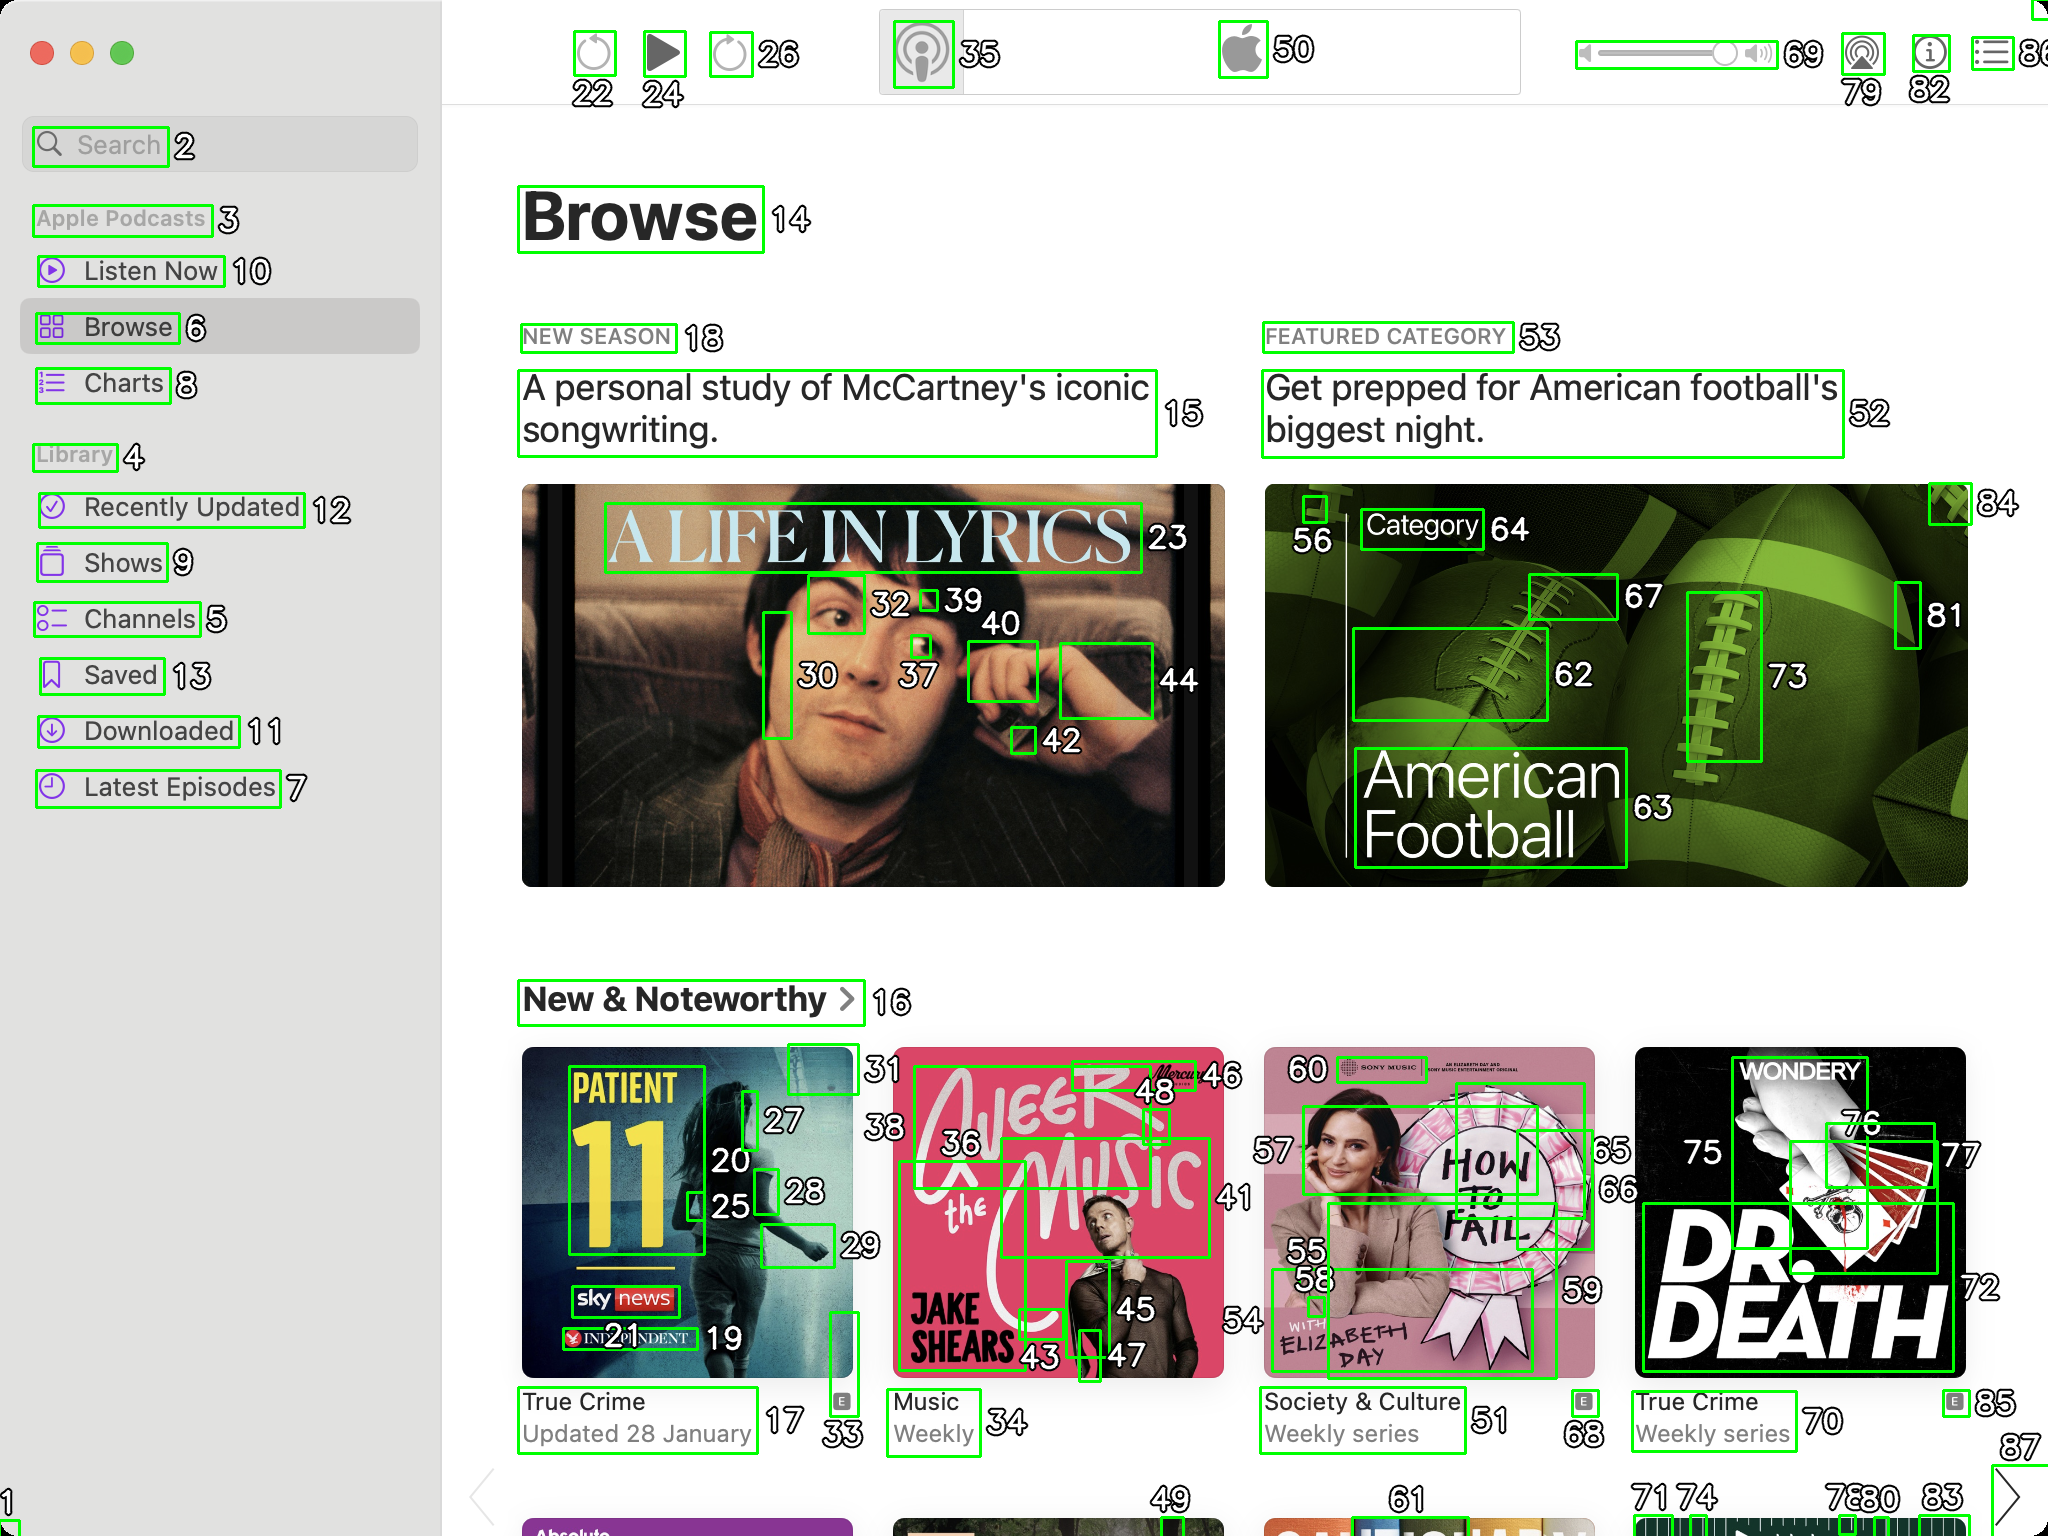You are an AI designed for image processing and segmentation analysis, particularly skilled in merging segmented regions of an image to improve accuracy and readability.

**Task Description:**
Your task is to address a user's concern with a UI screenshot of the Apple Podcasts application on MacOS. The screenshot contains multiple green boxes, each representing a UI element, with a unique white number outlined in black ranging from 1 to 88. Due to segmentation issues, some boxes that belong to the same image are divided unnaturally.

**Objective:**
Merge these segmented areas that correspond to a single UI element to create a coherent representation. The final output should be in JSON format, where each key-value pair represents the merged areas.

**Example JSON Output:**
If boxes with numbers 1, 2, and 3 should belong to the same UI element, the JSON output should be:

```json
{
    "Image A Life In Lyrics": [1, 2, 3]
}
```

**Instructions:**

- **Identify Segmented Regions:** Analyze the screenshot to identify which green boxes belong to the same UI element.
- **Merge Regions:** Group the numbers of these boxes together to represent a single UI element.
- **Output Format:** Produce the output in JSON format, with each key representing a UI element and each value being a list of the numbers of the merged boxes. Don't include in the result UI elements that consist of one box.

**Primary Objective:**
Ensure the accuracy of the merged regions based on the user's supplied image information, maintaining the integrity and structure of the UI elements in the Apple Podcasts application on MacOS. Based on the provided screenshot, here is the JSON output representing the merged segmented regions that correspond to single UI elements:

```json
{
    "Search": [2],
    "Apple Podcasts": [3],
    "Listen Now": [10],
    "Browse": [6, 14],
    "Charts": [8],
    "Library": [4],
    "Recently Updated": [12],
    "Shows": [9],
    "Channels": [5],
    "Saved": [13],
    "Downloaded": [11],
    "Latest Episodes": [7],
    "A Life In Lyrics": [23, 30, 32, 37, 39, 40, 42, 44],
    "New Season": [18],
    "A personal study of McCartney's iconic songwriting.": [15],
    "Featured Category": [53],
    "Get prepped for American football's biggest night.": [52],
    "Category": [64],
    "American Football": [62, 63, 67, 73, 81, 84],
    "New & Noteworthy": [16],
    "Patient 11": [17, 20, 25, 27, 28, 33],
    "True Crime Updated 28 January": [31],
    "A Beer With The Music": [36, 43, 45, 46, 48],
    "Weekly": [34],
    "How To Fail": [55, 56, 59, 60],
    "Society & Culture Weekly series": [51],
    "Dr. Death": [66, 68, 70, 72, 75, 76, 77],
    "True Crime Weekly series": [71, 74, 78, 80, 85]
}
```

This JSON output groups the segmented regions into coherent UI elements based on the provided screenshot. Each key represents a UI element, and the values are lists of the numbers of the merged boxes. 